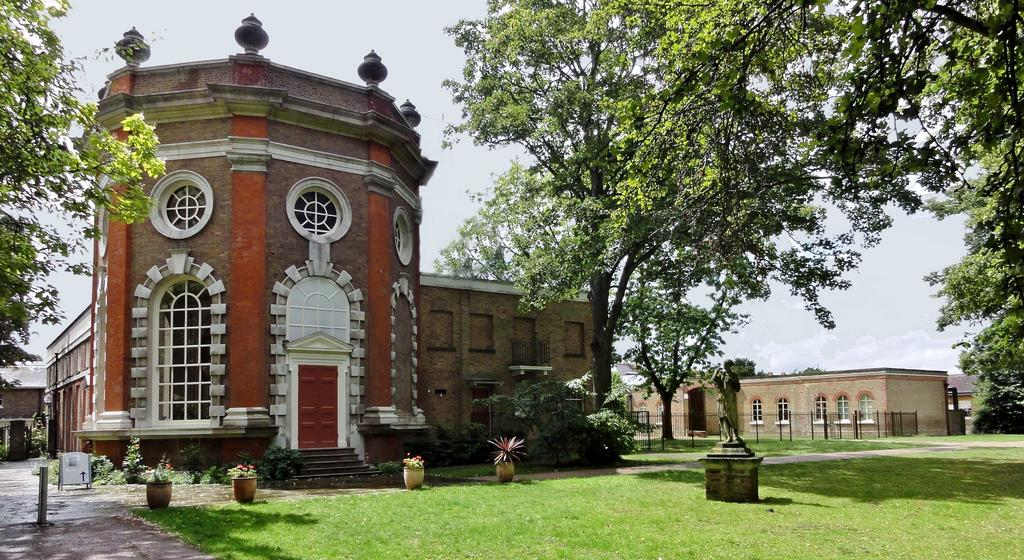What type of objects can be seen in the image? There are pots, trees, buildings, and a statue in the image. What type of terrain is visible in the image? There is grassy land in the image. What is the condition of the sky in the image? The sky is covered with clouds in the image. What type of protest is taking place in the image? There is no protest present in the image. Can you see a wrench being used in the image? There is no wrench present in the image. 